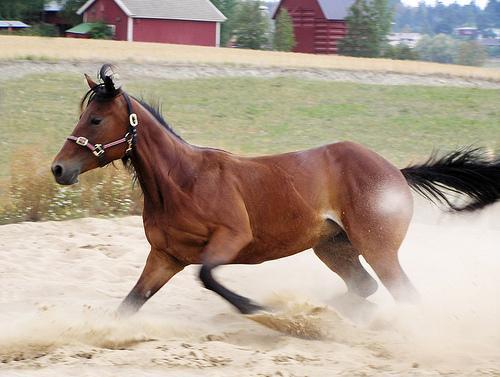How many types of animals are shown?
Give a very brief answer. 1. How many barns are shown?
Give a very brief answer. 2. 